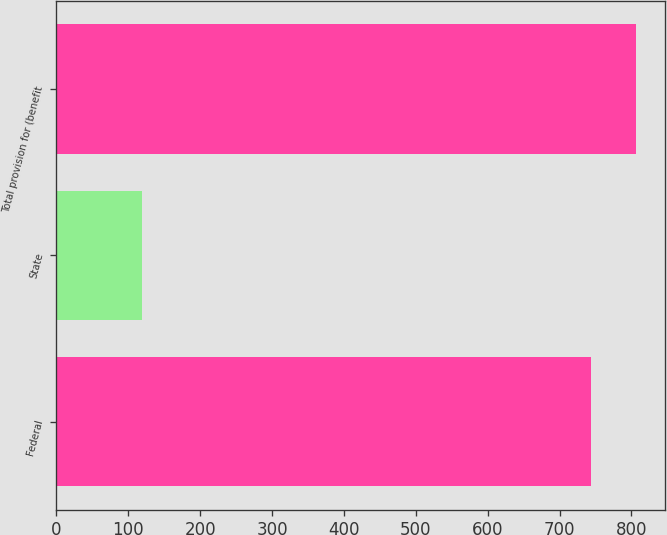Convert chart to OTSL. <chart><loc_0><loc_0><loc_500><loc_500><bar_chart><fcel>Federal<fcel>State<fcel>Total provision for (benefit<nl><fcel>743.4<fcel>119.3<fcel>806.85<nl></chart> 